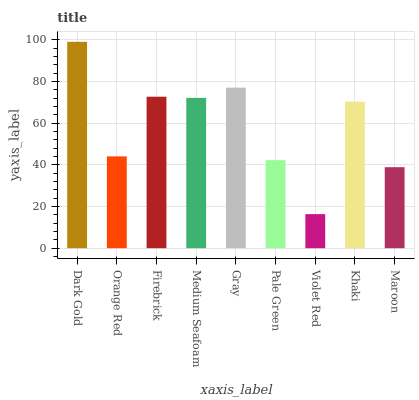Is Violet Red the minimum?
Answer yes or no. Yes. Is Dark Gold the maximum?
Answer yes or no. Yes. Is Orange Red the minimum?
Answer yes or no. No. Is Orange Red the maximum?
Answer yes or no. No. Is Dark Gold greater than Orange Red?
Answer yes or no. Yes. Is Orange Red less than Dark Gold?
Answer yes or no. Yes. Is Orange Red greater than Dark Gold?
Answer yes or no. No. Is Dark Gold less than Orange Red?
Answer yes or no. No. Is Khaki the high median?
Answer yes or no. Yes. Is Khaki the low median?
Answer yes or no. Yes. Is Firebrick the high median?
Answer yes or no. No. Is Maroon the low median?
Answer yes or no. No. 